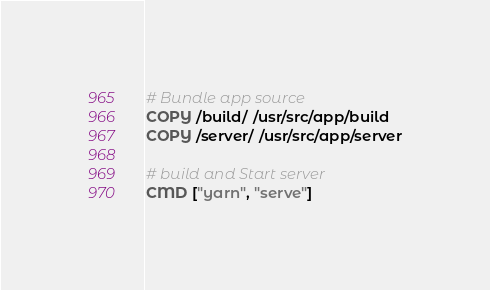<code> <loc_0><loc_0><loc_500><loc_500><_Dockerfile_>
# Bundle app source
COPY /build/ /usr/src/app/build
COPY /server/ /usr/src/app/server

# build and Start server
CMD ["yarn", "serve"]
</code> 